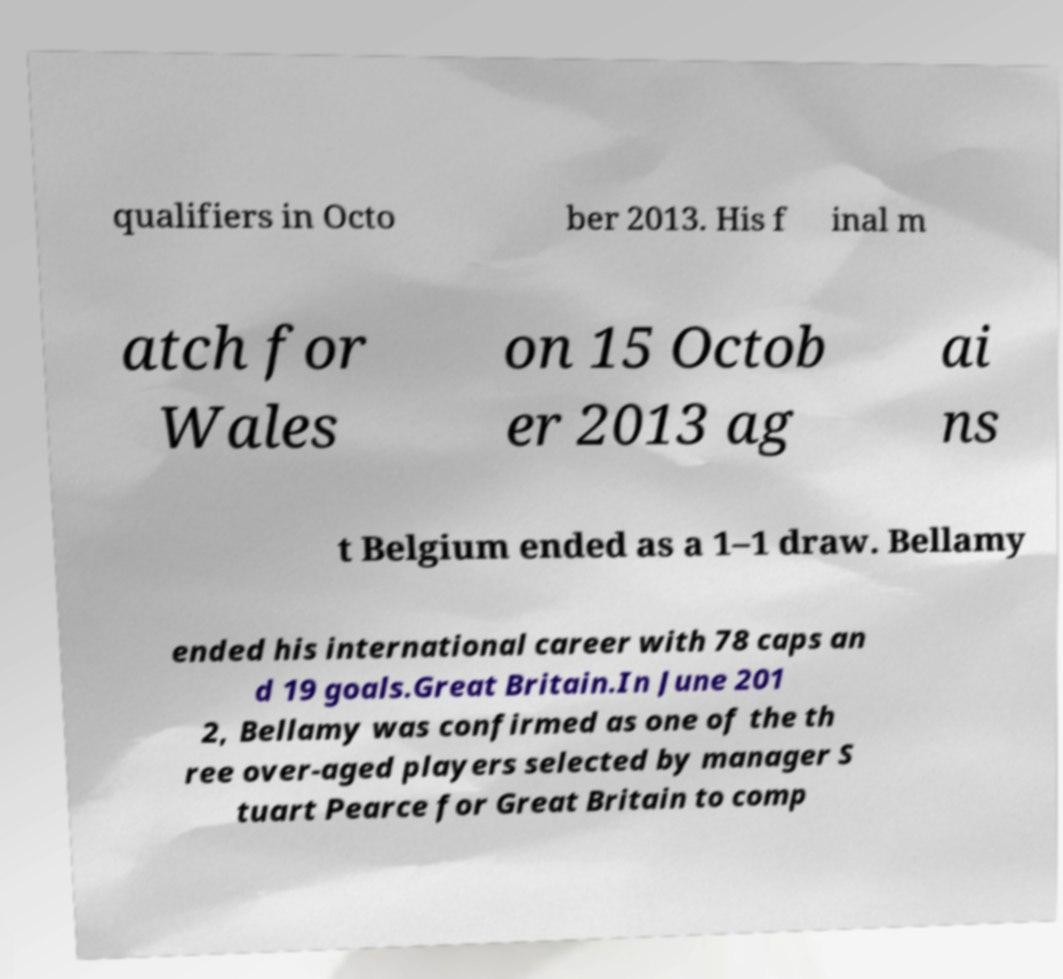Please identify and transcribe the text found in this image. qualifiers in Octo ber 2013. His f inal m atch for Wales on 15 Octob er 2013 ag ai ns t Belgium ended as a 1–1 draw. Bellamy ended his international career with 78 caps an d 19 goals.Great Britain.In June 201 2, Bellamy was confirmed as one of the th ree over-aged players selected by manager S tuart Pearce for Great Britain to comp 